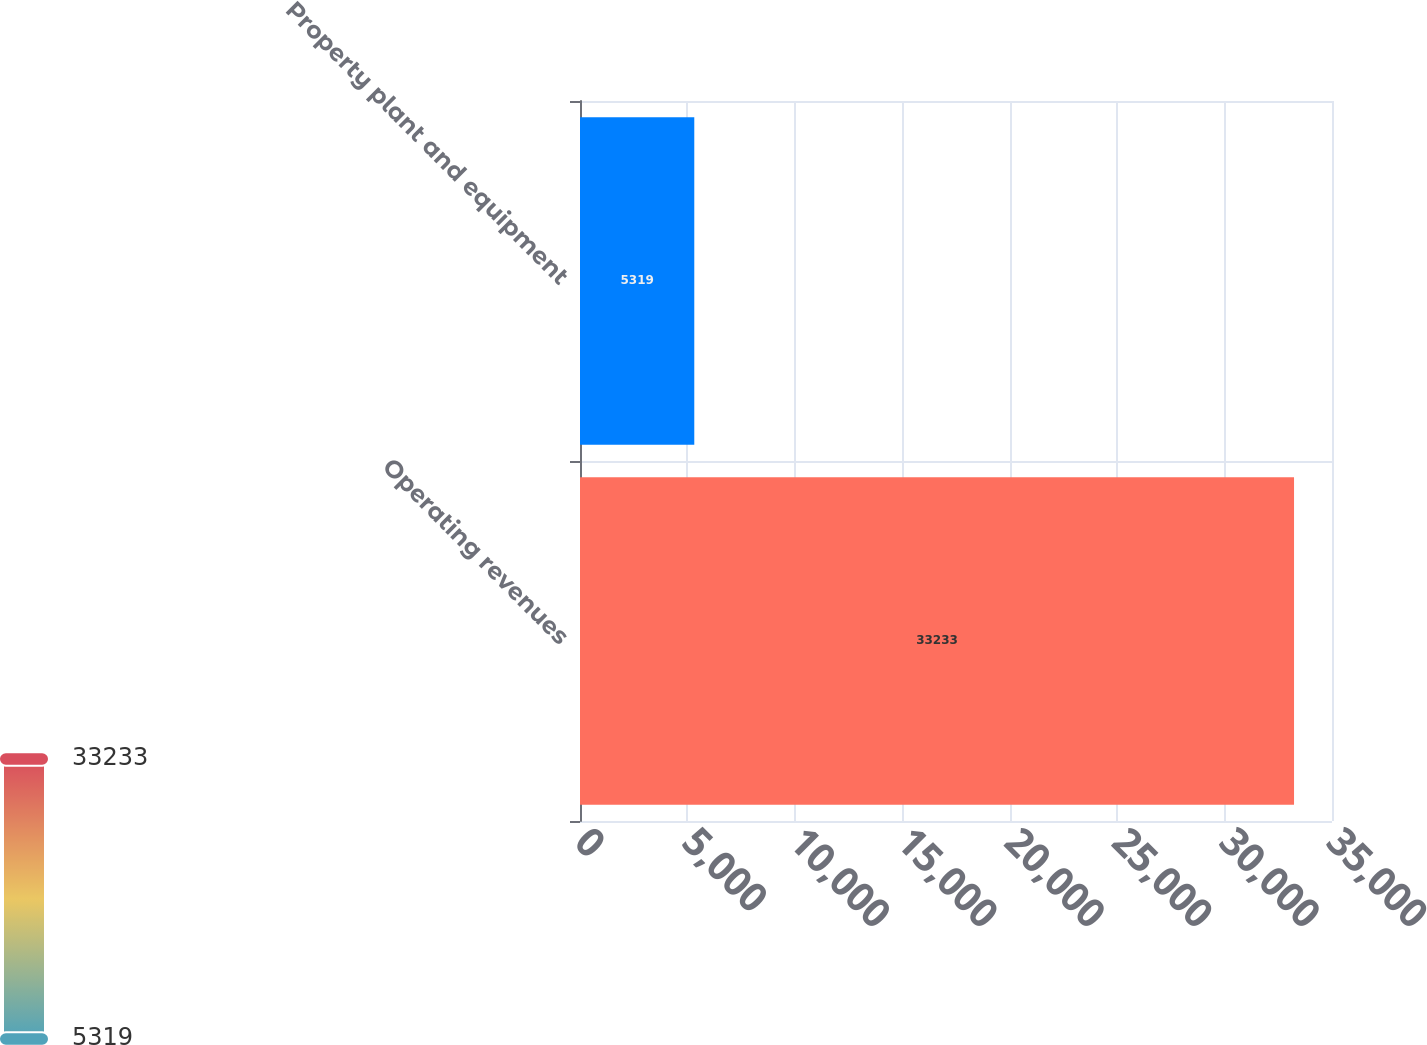<chart> <loc_0><loc_0><loc_500><loc_500><bar_chart><fcel>Operating revenues<fcel>Property plant and equipment<nl><fcel>33233<fcel>5319<nl></chart> 